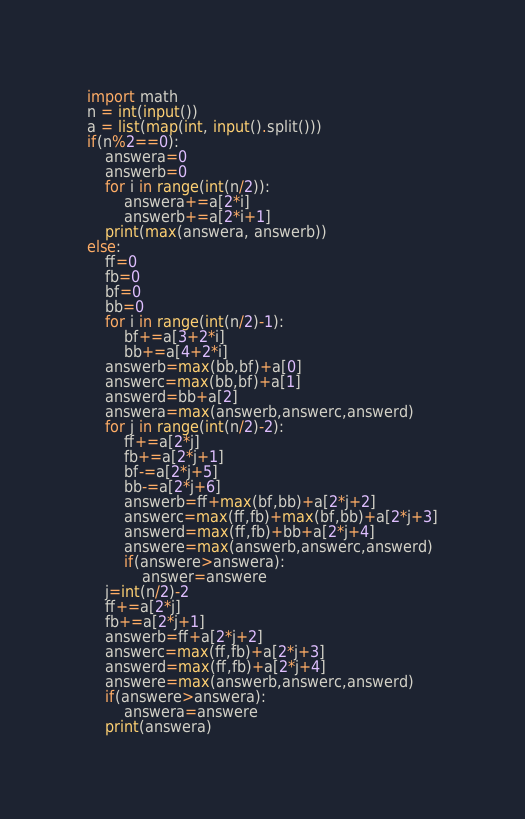Convert code to text. <code><loc_0><loc_0><loc_500><loc_500><_Python_>import math
n = int(input())
a = list(map(int, input().split()))
if(n%2==0):
    answera=0
    answerb=0
    for i in range(int(n/2)):
        answera+=a[2*i]
        answerb+=a[2*i+1]
    print(max(answera, answerb))
else:
    ff=0
    fb=0
    bf=0
    bb=0
    for i in range(int(n/2)-1):
        bf+=a[3+2*i]
        bb+=a[4+2*i]
    answerb=max(bb,bf)+a[0]
    answerc=max(bb,bf)+a[1]
    answerd=bb+a[2]       
    answera=max(answerb,answerc,answerd)
    for j in range(int(n/2)-2):
        ff+=a[2*j]
        fb+=a[2*j+1]
        bf-=a[2*j+5]
        bb-=a[2*j+6]
        answerb=ff+max(bf,bb)+a[2*j+2]
        answerc=max(ff,fb)+max(bf,bb)+a[2*j+3]
        answerd=max(ff,fb)+bb+a[2*j+4]
        answere=max(answerb,answerc,answerd)
        if(answere>answera):
            answer=answere
    j=int(n/2)-2
    ff+=a[2*j]
    fb+=a[2*j+1]
    answerb=ff+a[2*j+2]
    answerc=max(ff,fb)+a[2*j+3]
    answerd=max(ff,fb)+a[2*j+4]       
    answere=max(answerb,answerc,answerd)
    if(answere>answera):
        answera=answere
    print(answera)</code> 